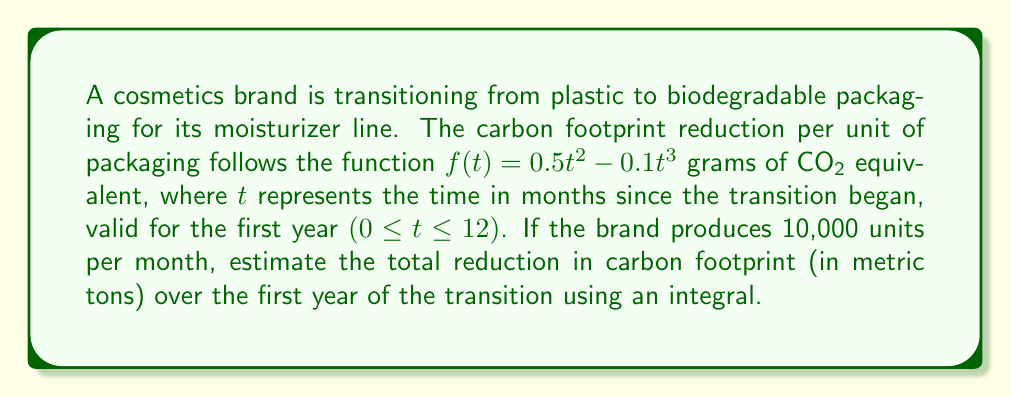Can you answer this question? To solve this problem, we need to follow these steps:

1) The function $f(t) = 0.5t^2 - 0.1t^3$ represents the carbon footprint reduction per unit of packaging.

2) To find the total reduction for all units over the year, we need to:
   a) Integrate this function over the interval $[0, 12]$ to get the reduction per unit over the year.
   b) Multiply the result by the number of units produced per month (10,000) and the number of months (12).

3) Let's start with the integral:

   $$\int_0^{12} (0.5t^2 - 0.1t^3) dt$$

4) Integrate using the power rule:

   $$\left[\frac{0.5t^3}{3} - \frac{0.1t^4}{4}\right]_0^{12}$$

5) Evaluate the integral:

   $$\left(\frac{0.5(12^3)}{3} - \frac{0.1(12^4)}{4}\right) - \left(\frac{0.5(0^3)}{3} - \frac{0.1(0^4)}{4}\right)$$
   
   $$= (288 - 345.6) - (0 - 0) = -57.6$$

6) This gives us the reduction per unit over the year in grams of CO₂ equivalent.

7) Multiply by the total number of units produced over the year:

   $$-57.6 \times 10,000 \times 12 = -6,912,000 \text{ grams of CO₂ equivalent}$$

8) Convert to metric tons:

   $$-6,912,000 \text{ grams} = -6.912 \text{ metric tons}$$

The negative sign indicates a reduction in carbon footprint.
Answer: The total reduction in carbon footprint over the first year of the transition is approximately 6.912 metric tons of CO₂ equivalent. 